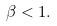<formula> <loc_0><loc_0><loc_500><loc_500>\beta < 1 .</formula> 